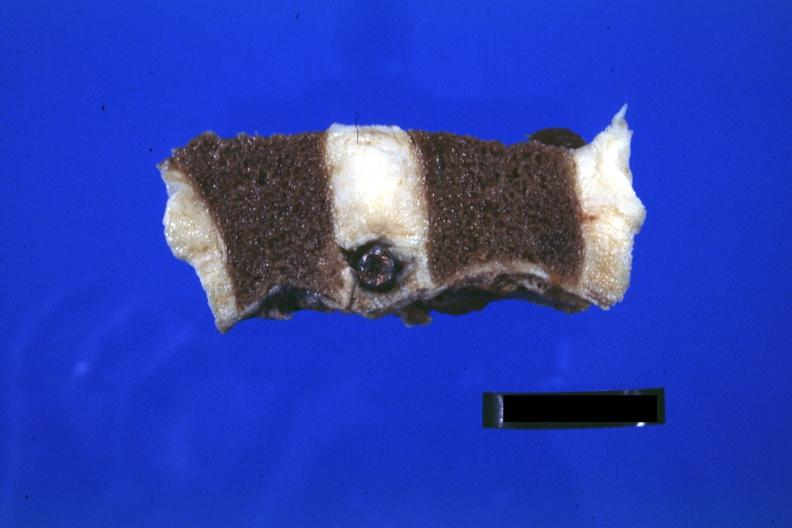s joints present?
Answer the question using a single word or phrase. Yes 